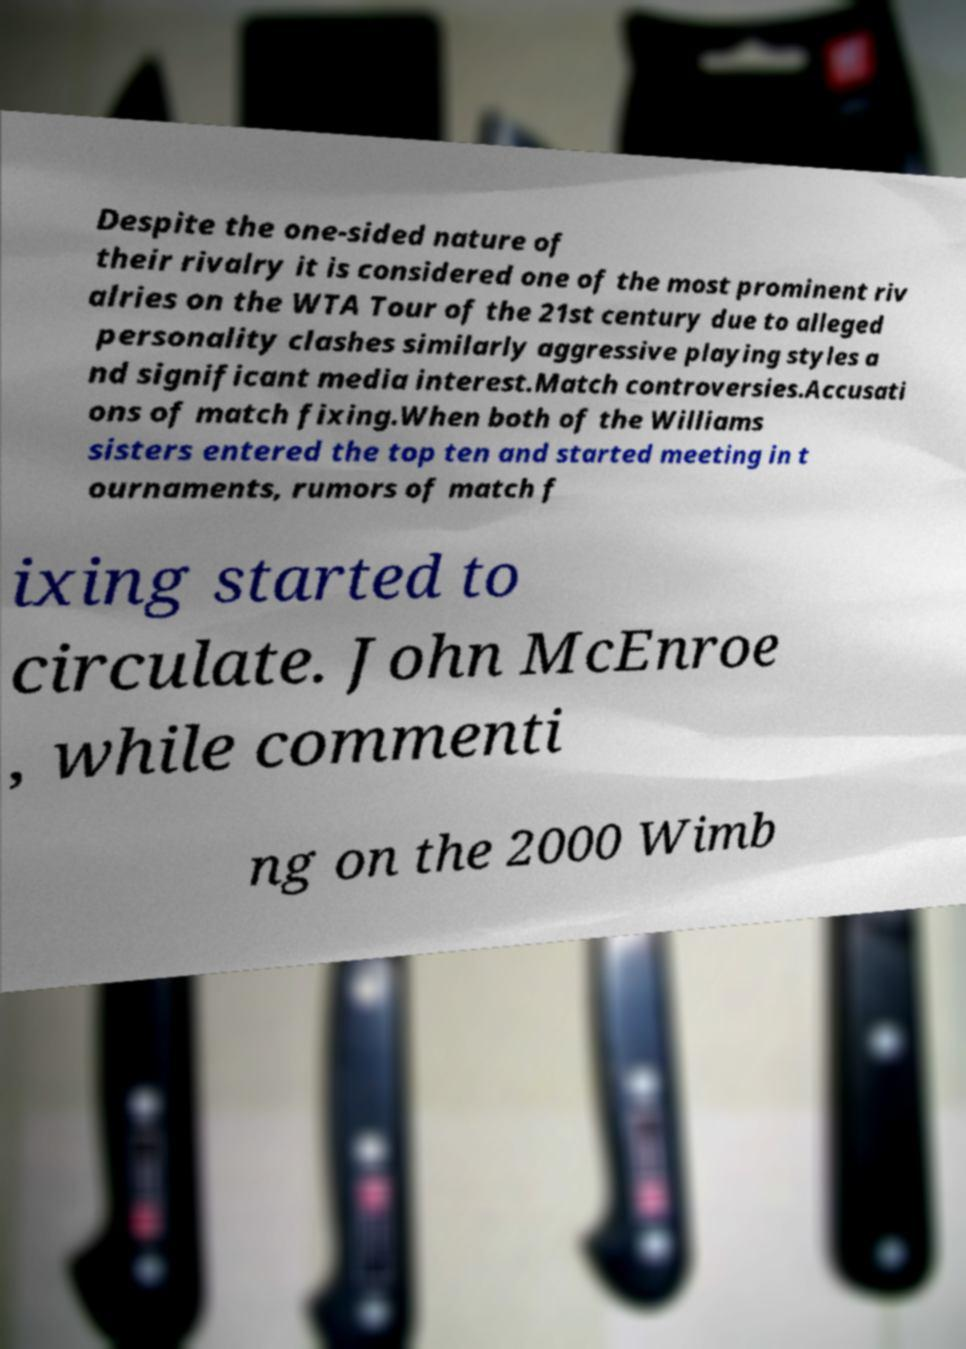What messages or text are displayed in this image? I need them in a readable, typed format. Despite the one-sided nature of their rivalry it is considered one of the most prominent riv alries on the WTA Tour of the 21st century due to alleged personality clashes similarly aggressive playing styles a nd significant media interest.Match controversies.Accusati ons of match fixing.When both of the Williams sisters entered the top ten and started meeting in t ournaments, rumors of match f ixing started to circulate. John McEnroe , while commenti ng on the 2000 Wimb 